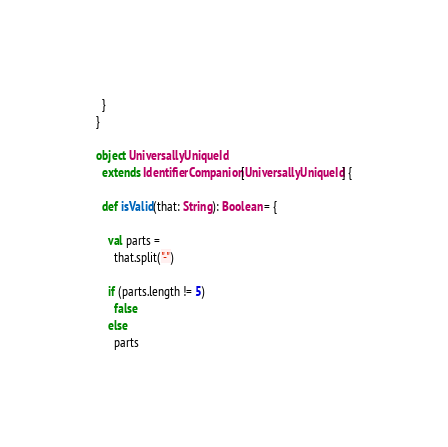<code> <loc_0><loc_0><loc_500><loc_500><_Scala_>  }
}

object UniversallyUniqueId
  extends IdentifierCompanion[UniversallyUniqueId] {

  def isValid(that: String): Boolean = {

    val parts =
      that.split("-")

    if (parts.length != 5)
      false
    else
      parts</code> 